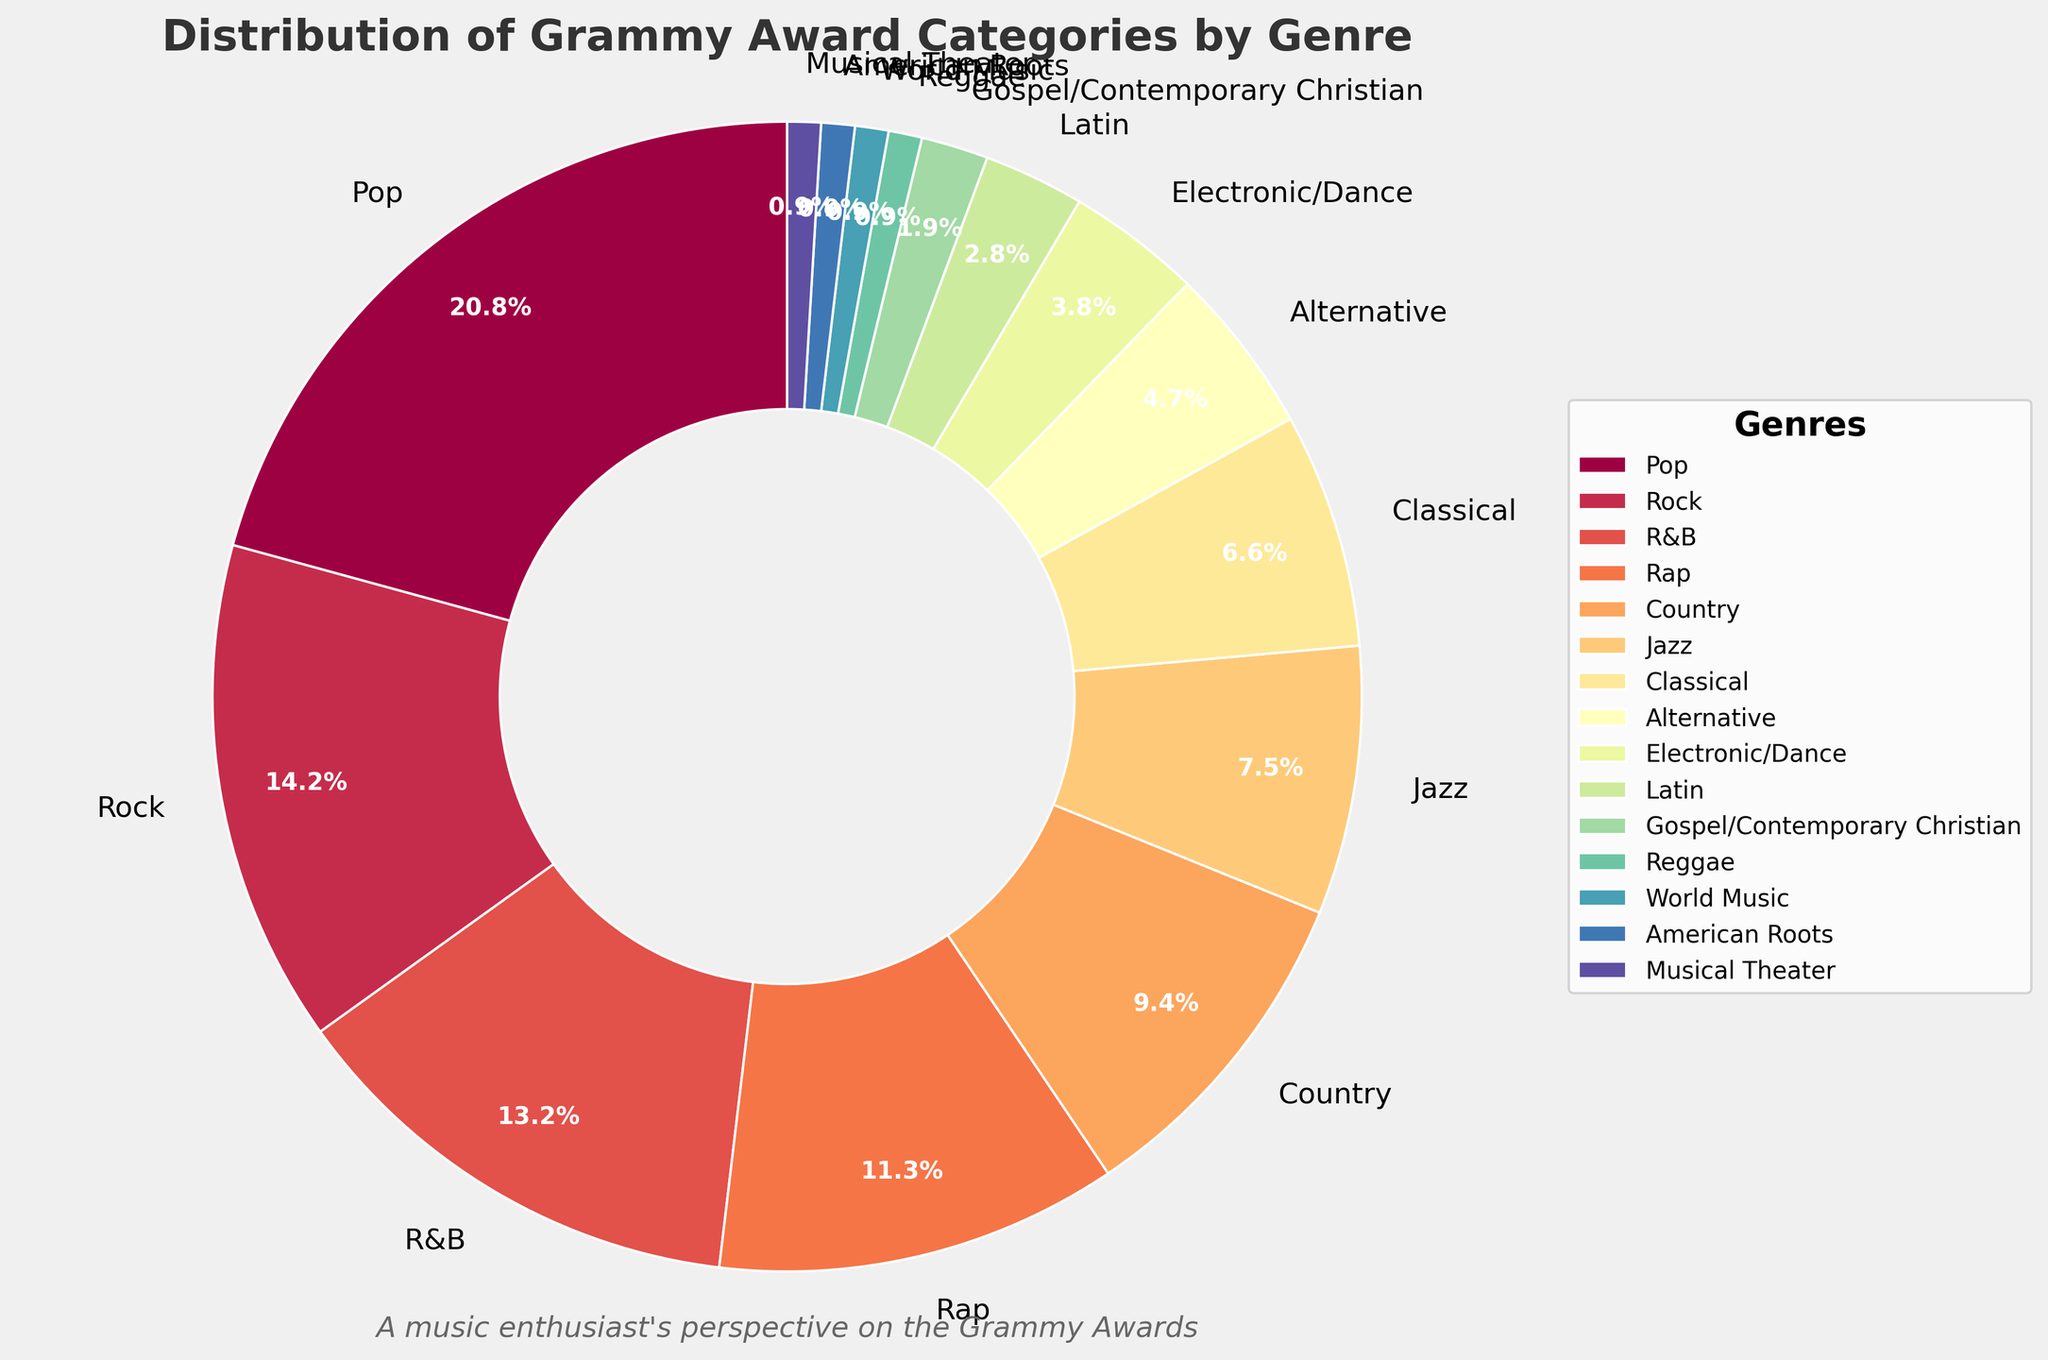Which genre has the highest percentage of Grammy Award categories? Look at the labels and percentages on the pie chart. The genre with the label "Pop" has the highest percentage of 22%.
Answer: Pop What is the total percentage of Grammy Award categories for Rock and R&B combined? Identify the percentages for Rock (15%) and R&B (14%), then sum them up: 15% + 14% = 29%.
Answer: 29% Which genre has twice the percentage of the Electronic/Dance genre? The percentage for Electronic/Dance is 4%. Checking the pie chart, the "R&B" genre has a percentage of 14%, which is close to twice (or a bit more than twice) the Electronic/Dance share.
Answer: R&B Is the percentage of Rap categories greater than Classical and Jazz combined? Rap has 12%, Classical has 7%, and Jazz has 8%. Combining Classical and Jazz gives 7% + 8% = 15%. Since 12% is less than 15%, the percentage of Rap is not greater.
Answer: No What percentage of the Grammy Award categories are made up by the four least represented genres? The least represented genres are Reggae, World Music, American Roots, and Musical Theater, each with 1%. Combine these: 1% + 1% + 1% + 1% = 4%.
Answer: 4% Apart from Pop, which genre has the next highest percentage? Exclude Pop. From the remaining pie chart pieces, the next highest percentages are Rock (15%) and R&B (14%). Rock has the higher percentage.
Answer: Rock How does the percentage of Country categories compare to Classical? Country has a percentage of 10%, and Classical has 7%. Since 10% is greater than 7%, the Country genre has a higher percentage.
Answer: Country is greater Which genre has a percentage closest to the midpoint of 5% and 10%? The midpoint between 5% and 10% is 7.5%. The genre closest to this value is Classical, with a percentage of 7%.
Answer: Classical By how much does the percentage of Pop categories exceed the percentage of Latin categories? The percentage of Pop is 22%, and Latin is 3%. The difference is 22% - 3% = 19%.
Answer: 19% 